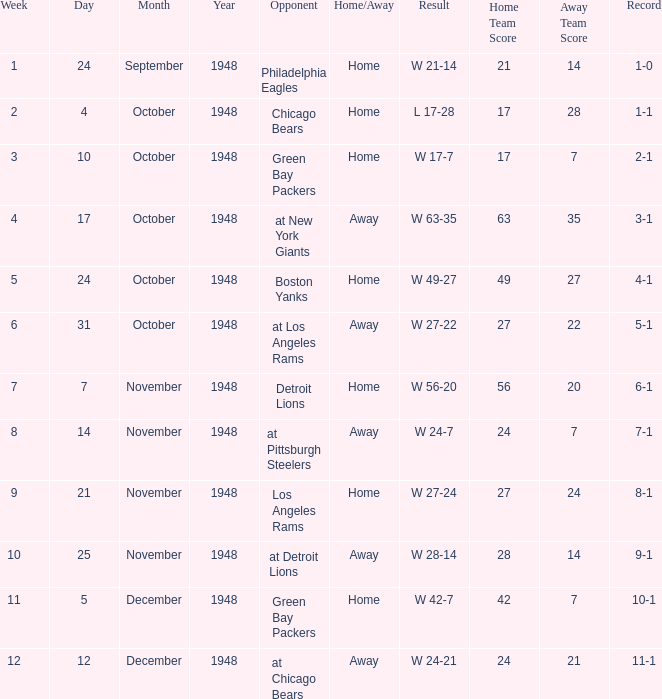What date was the opponent the Boston Yanks? October 24, 1948. 